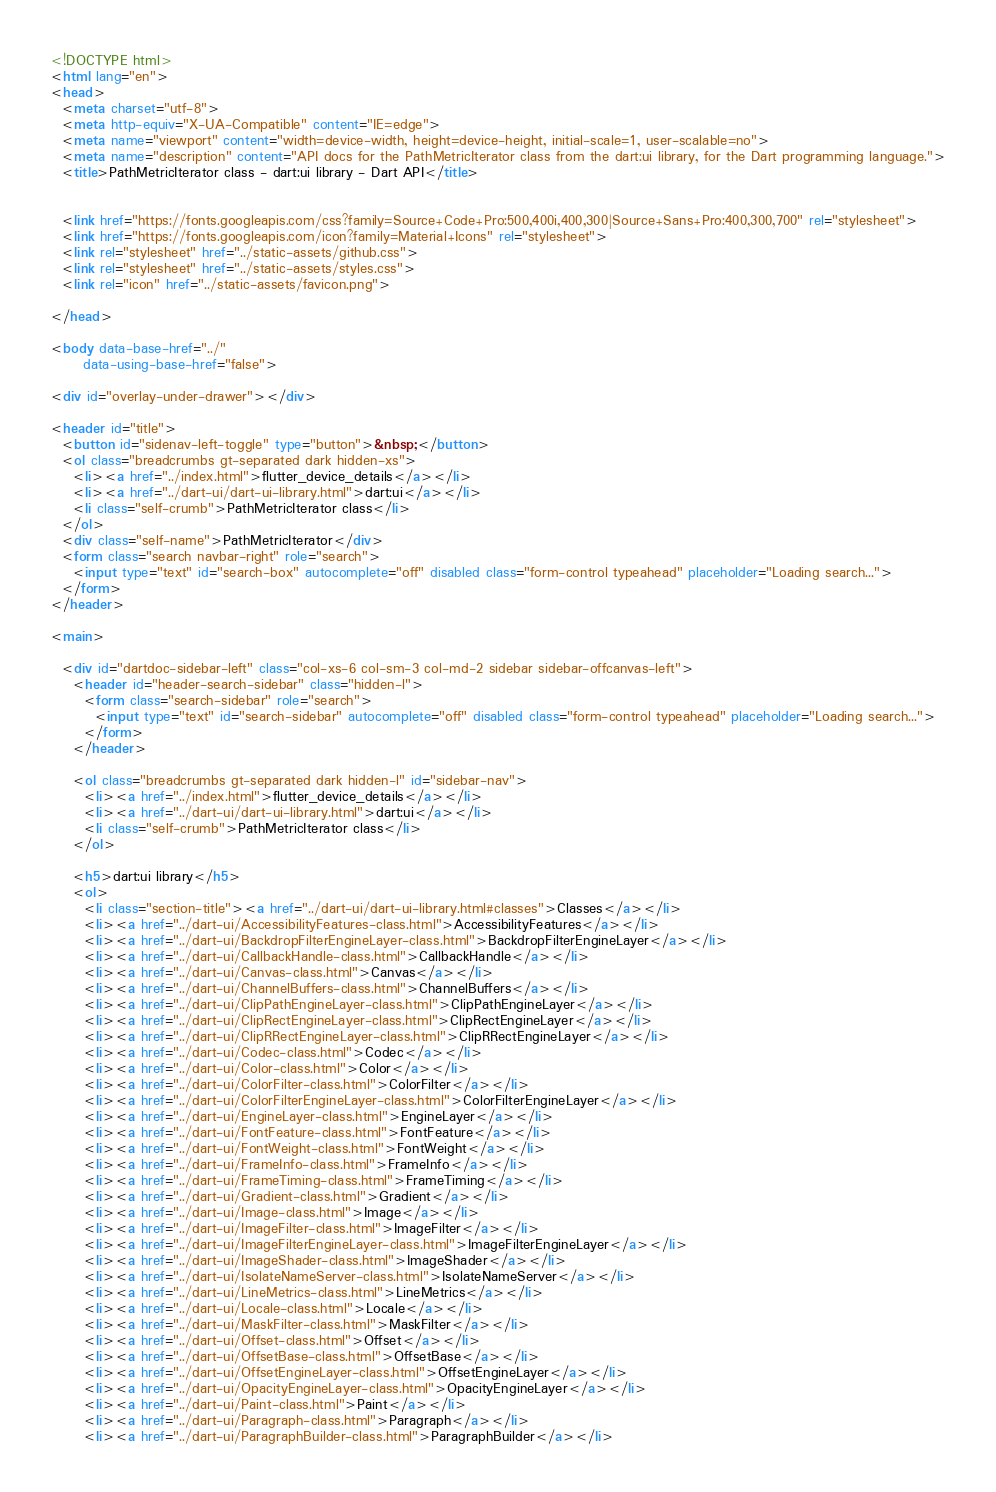Convert code to text. <code><loc_0><loc_0><loc_500><loc_500><_HTML_><!DOCTYPE html>
<html lang="en">
<head>
  <meta charset="utf-8">
  <meta http-equiv="X-UA-Compatible" content="IE=edge">
  <meta name="viewport" content="width=device-width, height=device-height, initial-scale=1, user-scalable=no">
  <meta name="description" content="API docs for the PathMetricIterator class from the dart:ui library, for the Dart programming language.">
  <title>PathMetricIterator class - dart:ui library - Dart API</title>

  
  <link href="https://fonts.googleapis.com/css?family=Source+Code+Pro:500,400i,400,300|Source+Sans+Pro:400,300,700" rel="stylesheet">
  <link href="https://fonts.googleapis.com/icon?family=Material+Icons" rel="stylesheet">
  <link rel="stylesheet" href="../static-assets/github.css">
  <link rel="stylesheet" href="../static-assets/styles.css">
  <link rel="icon" href="../static-assets/favicon.png">

</head>

<body data-base-href="../"
      data-using-base-href="false">

<div id="overlay-under-drawer"></div>

<header id="title">
  <button id="sidenav-left-toggle" type="button">&nbsp;</button>
  <ol class="breadcrumbs gt-separated dark hidden-xs">
    <li><a href="../index.html">flutter_device_details</a></li>
    <li><a href="../dart-ui/dart-ui-library.html">dart:ui</a></li>
    <li class="self-crumb">PathMetricIterator class</li>
  </ol>
  <div class="self-name">PathMetricIterator</div>
  <form class="search navbar-right" role="search">
    <input type="text" id="search-box" autocomplete="off" disabled class="form-control typeahead" placeholder="Loading search...">
  </form>
</header>

<main>

  <div id="dartdoc-sidebar-left" class="col-xs-6 col-sm-3 col-md-2 sidebar sidebar-offcanvas-left">
    <header id="header-search-sidebar" class="hidden-l">
      <form class="search-sidebar" role="search">
        <input type="text" id="search-sidebar" autocomplete="off" disabled class="form-control typeahead" placeholder="Loading search...">
      </form>
    </header>
    
    <ol class="breadcrumbs gt-separated dark hidden-l" id="sidebar-nav">
      <li><a href="../index.html">flutter_device_details</a></li>
      <li><a href="../dart-ui/dart-ui-library.html">dart:ui</a></li>
      <li class="self-crumb">PathMetricIterator class</li>
    </ol>
    
    <h5>dart:ui library</h5>
    <ol>
      <li class="section-title"><a href="../dart-ui/dart-ui-library.html#classes">Classes</a></li>
      <li><a href="../dart-ui/AccessibilityFeatures-class.html">AccessibilityFeatures</a></li>
      <li><a href="../dart-ui/BackdropFilterEngineLayer-class.html">BackdropFilterEngineLayer</a></li>
      <li><a href="../dart-ui/CallbackHandle-class.html">CallbackHandle</a></li>
      <li><a href="../dart-ui/Canvas-class.html">Canvas</a></li>
      <li><a href="../dart-ui/ChannelBuffers-class.html">ChannelBuffers</a></li>
      <li><a href="../dart-ui/ClipPathEngineLayer-class.html">ClipPathEngineLayer</a></li>
      <li><a href="../dart-ui/ClipRectEngineLayer-class.html">ClipRectEngineLayer</a></li>
      <li><a href="../dart-ui/ClipRRectEngineLayer-class.html">ClipRRectEngineLayer</a></li>
      <li><a href="../dart-ui/Codec-class.html">Codec</a></li>
      <li><a href="../dart-ui/Color-class.html">Color</a></li>
      <li><a href="../dart-ui/ColorFilter-class.html">ColorFilter</a></li>
      <li><a href="../dart-ui/ColorFilterEngineLayer-class.html">ColorFilterEngineLayer</a></li>
      <li><a href="../dart-ui/EngineLayer-class.html">EngineLayer</a></li>
      <li><a href="../dart-ui/FontFeature-class.html">FontFeature</a></li>
      <li><a href="../dart-ui/FontWeight-class.html">FontWeight</a></li>
      <li><a href="../dart-ui/FrameInfo-class.html">FrameInfo</a></li>
      <li><a href="../dart-ui/FrameTiming-class.html">FrameTiming</a></li>
      <li><a href="../dart-ui/Gradient-class.html">Gradient</a></li>
      <li><a href="../dart-ui/Image-class.html">Image</a></li>
      <li><a href="../dart-ui/ImageFilter-class.html">ImageFilter</a></li>
      <li><a href="../dart-ui/ImageFilterEngineLayer-class.html">ImageFilterEngineLayer</a></li>
      <li><a href="../dart-ui/ImageShader-class.html">ImageShader</a></li>
      <li><a href="../dart-ui/IsolateNameServer-class.html">IsolateNameServer</a></li>
      <li><a href="../dart-ui/LineMetrics-class.html">LineMetrics</a></li>
      <li><a href="../dart-ui/Locale-class.html">Locale</a></li>
      <li><a href="../dart-ui/MaskFilter-class.html">MaskFilter</a></li>
      <li><a href="../dart-ui/Offset-class.html">Offset</a></li>
      <li><a href="../dart-ui/OffsetBase-class.html">OffsetBase</a></li>
      <li><a href="../dart-ui/OffsetEngineLayer-class.html">OffsetEngineLayer</a></li>
      <li><a href="../dart-ui/OpacityEngineLayer-class.html">OpacityEngineLayer</a></li>
      <li><a href="../dart-ui/Paint-class.html">Paint</a></li>
      <li><a href="../dart-ui/Paragraph-class.html">Paragraph</a></li>
      <li><a href="../dart-ui/ParagraphBuilder-class.html">ParagraphBuilder</a></li></code> 